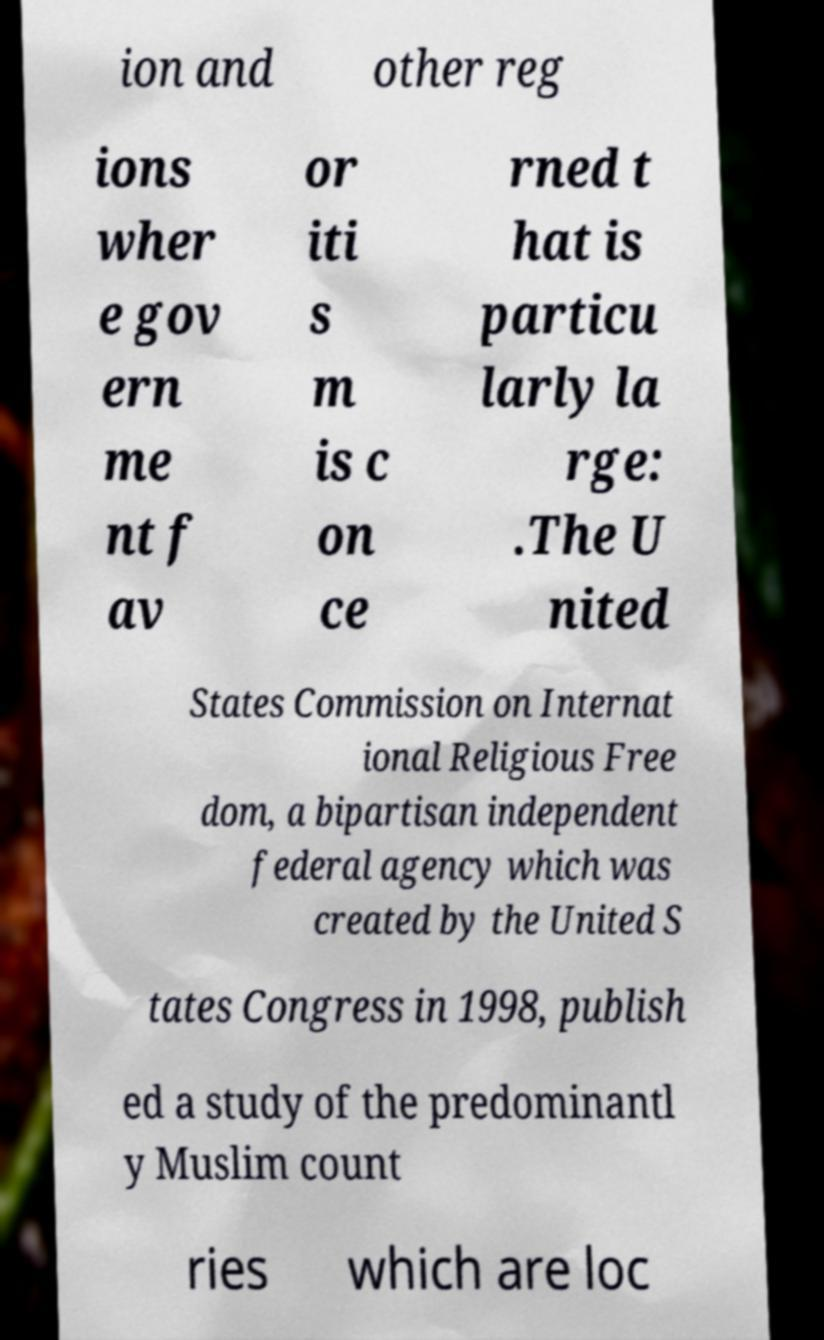Could you assist in decoding the text presented in this image and type it out clearly? ion and other reg ions wher e gov ern me nt f av or iti s m is c on ce rned t hat is particu larly la rge: .The U nited States Commission on Internat ional Religious Free dom, a bipartisan independent federal agency which was created by the United S tates Congress in 1998, publish ed a study of the predominantl y Muslim count ries which are loc 